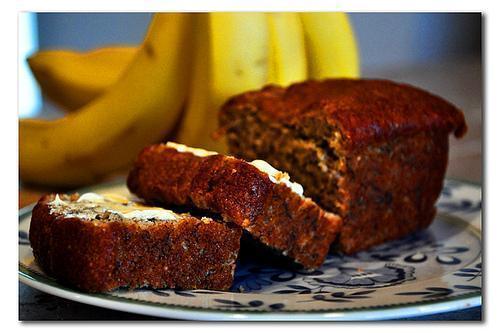How many cakes are in the photo?
Give a very brief answer. 3. How many bananas are there?
Give a very brief answer. 1. 